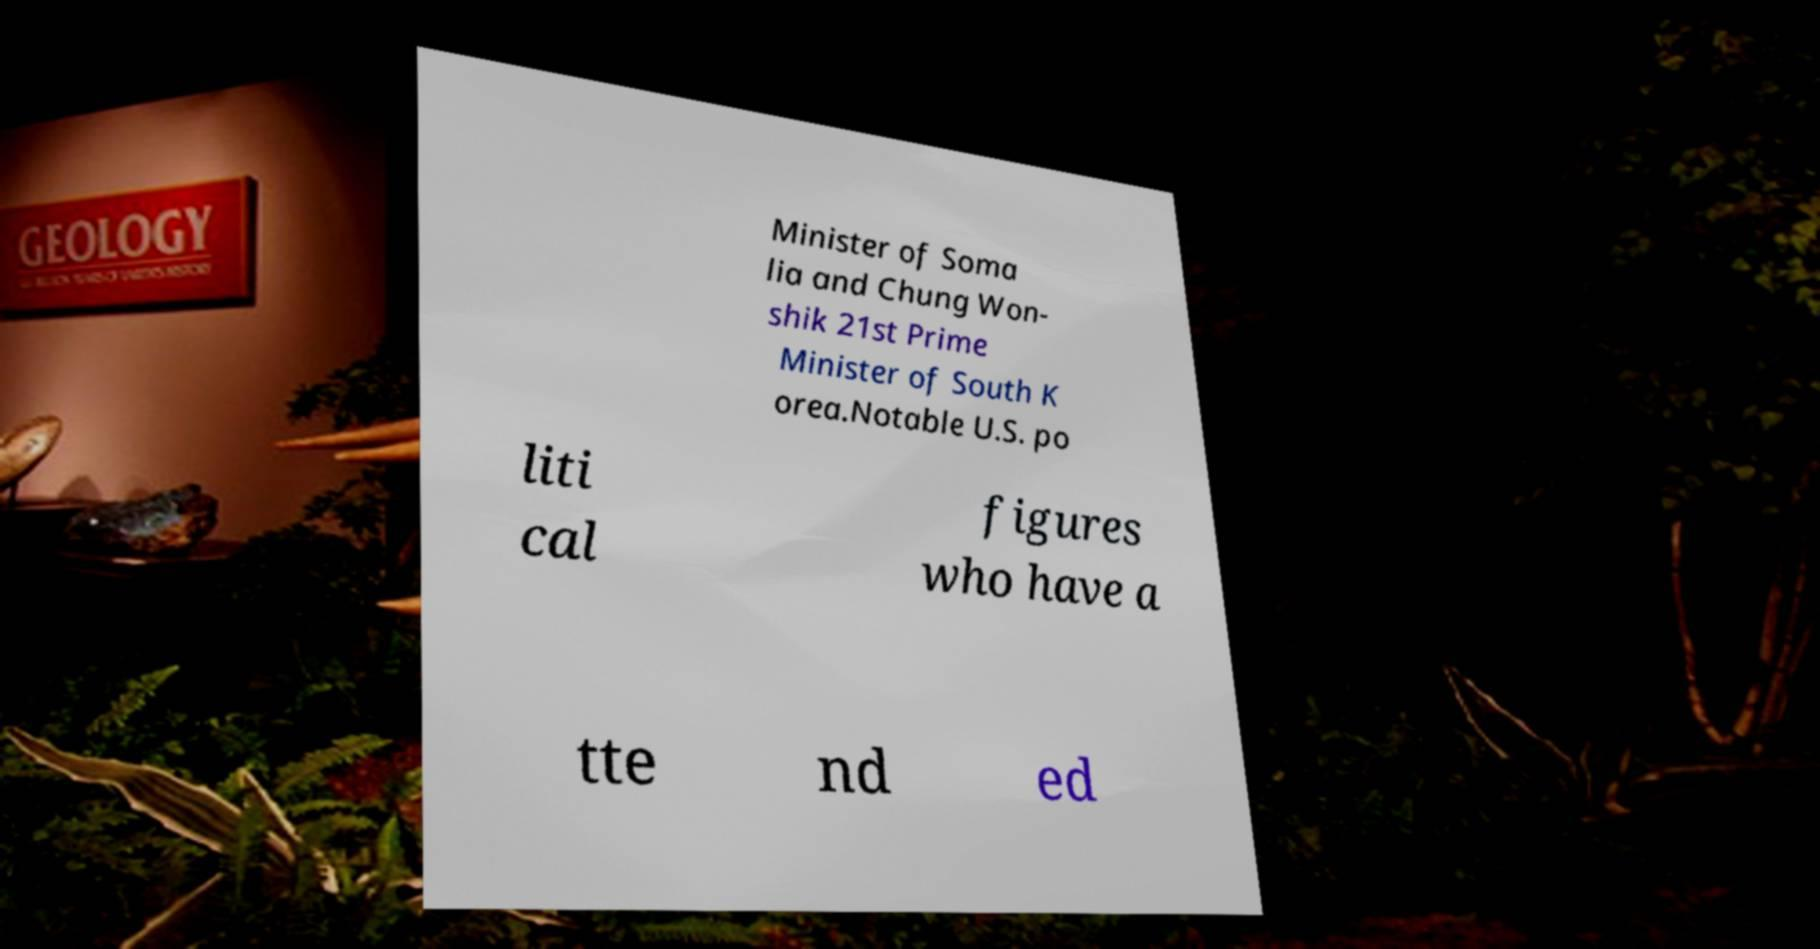Can you read and provide the text displayed in the image?This photo seems to have some interesting text. Can you extract and type it out for me? Minister of Soma lia and Chung Won- shik 21st Prime Minister of South K orea.Notable U.S. po liti cal figures who have a tte nd ed 